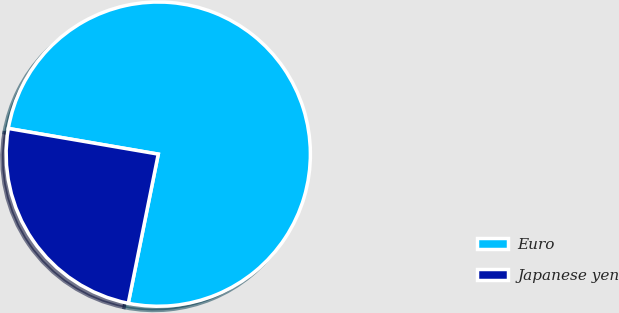Convert chart to OTSL. <chart><loc_0><loc_0><loc_500><loc_500><pie_chart><fcel>Euro<fcel>Japanese yen<nl><fcel>75.46%<fcel>24.54%<nl></chart> 